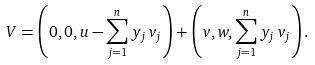<formula> <loc_0><loc_0><loc_500><loc_500>V = \left ( 0 , 0 , u - \sum _ { j = 1 } ^ { n } y _ { j } \, v _ { j } \right ) + \left ( v , w , \sum _ { j = 1 } ^ { n } y _ { j } \, v _ { j } \right ) .</formula> 